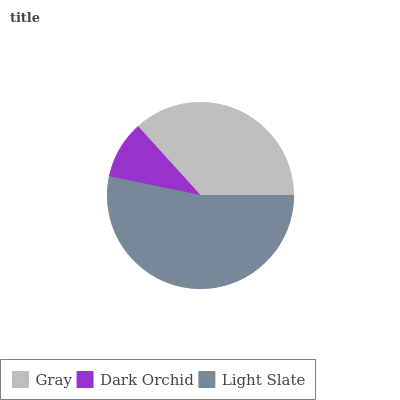Is Dark Orchid the minimum?
Answer yes or no. Yes. Is Light Slate the maximum?
Answer yes or no. Yes. Is Light Slate the minimum?
Answer yes or no. No. Is Dark Orchid the maximum?
Answer yes or no. No. Is Light Slate greater than Dark Orchid?
Answer yes or no. Yes. Is Dark Orchid less than Light Slate?
Answer yes or no. Yes. Is Dark Orchid greater than Light Slate?
Answer yes or no. No. Is Light Slate less than Dark Orchid?
Answer yes or no. No. Is Gray the high median?
Answer yes or no. Yes. Is Gray the low median?
Answer yes or no. Yes. Is Dark Orchid the high median?
Answer yes or no. No. Is Light Slate the low median?
Answer yes or no. No. 